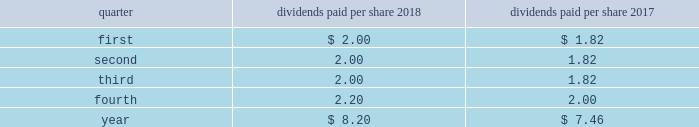Part ii item 5 .
Market for registrant 2019s common equity , related stockholder matters and issuer purchases of equity securities at january 25 , 2019 , we had 26812 holders of record of our common stock , par value $ 1 per share .
Our common stock is traded on the new york stock exchange ( nyse ) under the symbol lmt .
Information concerning dividends paid on lockheed martin common stock during the past two years is as follows : common stock - dividends paid per share .
Stockholder return performance graph the following graph compares the total return on a cumulative basis of $ 100 invested in lockheed martin common stock on december 31 , 2013 to the standard and poor 2019s ( s&p ) 500 index and the s&p aerospace & defense index .
The s&p aerospace & defense index comprises arconic inc. , general dynamics corporation , harris corporation , huntington ingalls industries , l3 technologies , inc. , lockheed martin corporation , northrop grumman corporation , raytheon company , textron inc. , the boeing company , transdigm group inc. , and united technologies corporation .
The stockholder return performance indicated on the graph is not a guarantee of future performance. .
What is the net change in total dividends paid per share from 2017 to 2018? 
Computations: (8.20 - 7.46)
Answer: 0.74. 